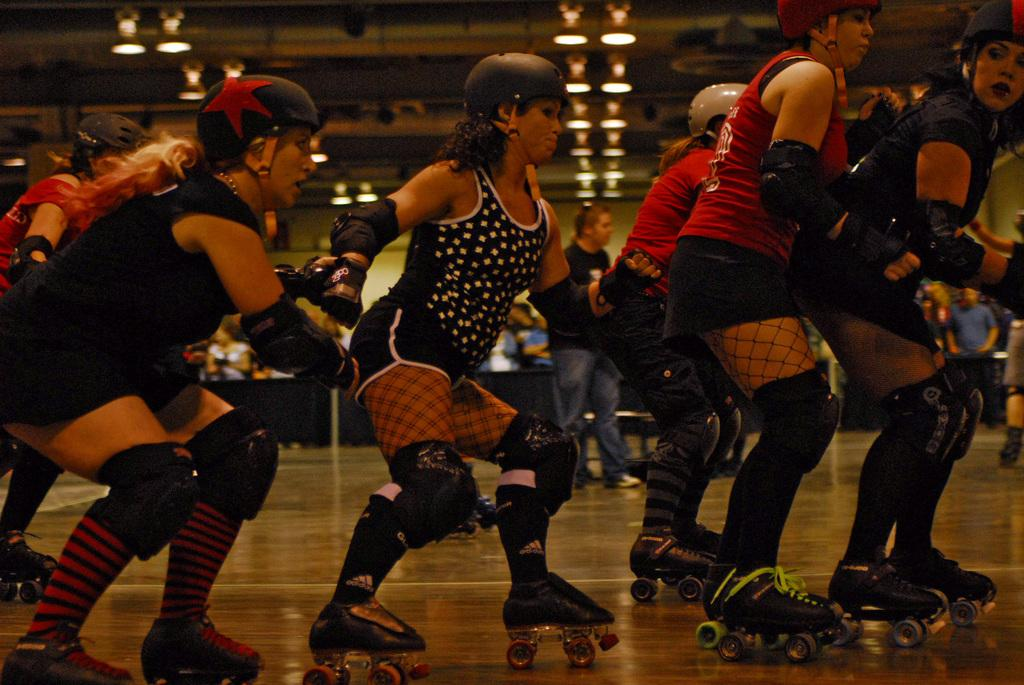What are the women in the image doing? The women are skating in the image. What can be seen in the background of the image? There is a wall in the background of the image. What is the color of the wall? The wall is green in color. What part of the room is visible at the top of the image? The ceiling of the room is visible at the top of the image. What type of chin can be seen on the women in the image? There is no chin visible on the women in the image, as their faces are not shown. 